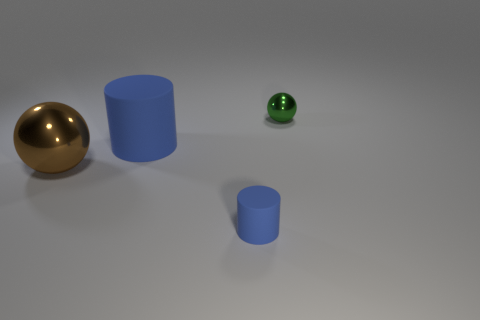What number of other cylinders are the same color as the tiny rubber cylinder?
Keep it short and to the point. 1. Do the big rubber cylinder and the cylinder in front of the large brown object have the same color?
Your answer should be compact. Yes. Is the number of tiny blue objects less than the number of big things?
Provide a succinct answer. Yes. Is the number of tiny green metal objects on the right side of the tiny blue rubber thing greater than the number of tiny metal objects behind the tiny metal object?
Ensure brevity in your answer.  Yes. Is the material of the small blue object the same as the green ball?
Provide a succinct answer. No. There is a big thing on the left side of the big matte cylinder; how many blue cylinders are on the left side of it?
Give a very brief answer. 0. Does the small object that is to the left of the small green sphere have the same color as the large rubber cylinder?
Your answer should be very brief. Yes. How many things are blue matte things or rubber objects that are behind the small rubber object?
Provide a short and direct response. 2. There is a shiny object left of the small rubber object; does it have the same shape as the metallic object behind the large matte object?
Offer a terse response. Yes. Are there any other things that are the same color as the large shiny object?
Your response must be concise. No. 